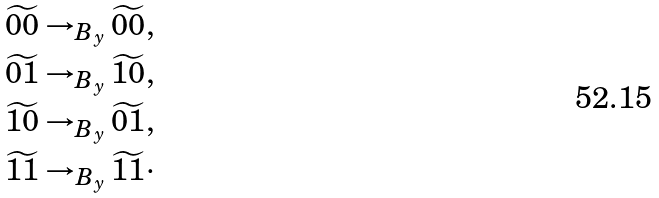Convert formula to latex. <formula><loc_0><loc_0><loc_500><loc_500>\widetilde { 0 0 } \rightarrow _ { B _ { y } } \widetilde { 0 0 } , \\ \widetilde { 0 1 } \rightarrow _ { B _ { y } } \widetilde { 1 0 } , \\ \widetilde { 1 0 } \rightarrow _ { B _ { y } } \widetilde { 0 1 } , \\ \widetilde { 1 1 } \rightarrow _ { B _ { y } } \widetilde { 1 1 } \cdot</formula> 